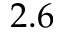Convert formula to latex. <formula><loc_0><loc_0><loc_500><loc_500>2 . 6</formula> 